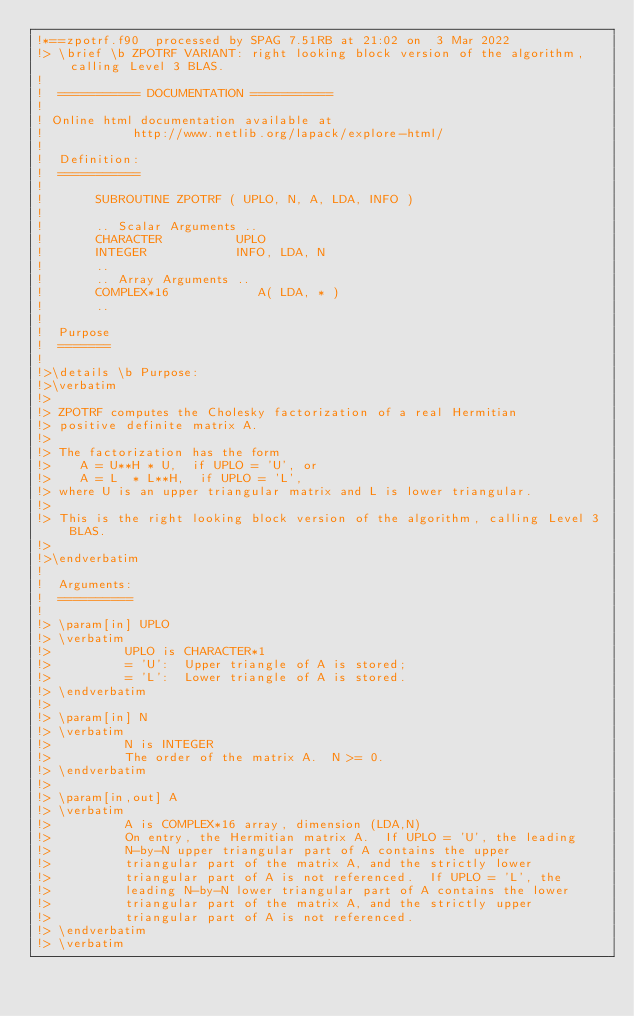Convert code to text. <code><loc_0><loc_0><loc_500><loc_500><_FORTRAN_>!*==zpotrf.f90  processed by SPAG 7.51RB at 21:02 on  3 Mar 2022
!> \brief \b ZPOTRF VARIANT: right looking block version of the algorithm, calling Level 3 BLAS.
!
!  =========== DOCUMENTATION ===========
!
! Online html documentation available at
!            http://www.netlib.org/lapack/explore-html/
!
!  Definition:
!  ===========
!
!       SUBROUTINE ZPOTRF ( UPLO, N, A, LDA, INFO )
!
!       .. Scalar Arguments ..
!       CHARACTER          UPLO
!       INTEGER            INFO, LDA, N
!       ..
!       .. Array Arguments ..
!       COMPLEX*16            A( LDA, * )
!       ..
!
!  Purpose
!  =======
!
!>\details \b Purpose:
!>\verbatim
!>
!> ZPOTRF computes the Cholesky factorization of a real Hermitian
!> positive definite matrix A.
!>
!> The factorization has the form
!>    A = U**H * U,  if UPLO = 'U', or
!>    A = L  * L**H,  if UPLO = 'L',
!> where U is an upper triangular matrix and L is lower triangular.
!>
!> This is the right looking block version of the algorithm, calling Level 3 BLAS.
!>
!>\endverbatim
!
!  Arguments:
!  ==========
!
!> \param[in] UPLO
!> \verbatim
!>          UPLO is CHARACTER*1
!>          = 'U':  Upper triangle of A is stored;
!>          = 'L':  Lower triangle of A is stored.
!> \endverbatim
!>
!> \param[in] N
!> \verbatim
!>          N is INTEGER
!>          The order of the matrix A.  N >= 0.
!> \endverbatim
!>
!> \param[in,out] A
!> \verbatim
!>          A is COMPLEX*16 array, dimension (LDA,N)
!>          On entry, the Hermitian matrix A.  If UPLO = 'U', the leading
!>          N-by-N upper triangular part of A contains the upper
!>          triangular part of the matrix A, and the strictly lower
!>          triangular part of A is not referenced.  If UPLO = 'L', the
!>          leading N-by-N lower triangular part of A contains the lower
!>          triangular part of the matrix A, and the strictly upper
!>          triangular part of A is not referenced.
!> \endverbatim
!> \verbatim</code> 